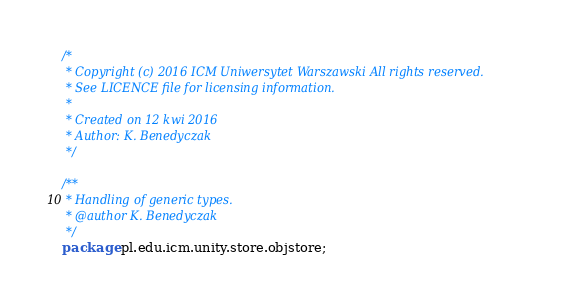<code> <loc_0><loc_0><loc_500><loc_500><_Java_>/*
 * Copyright (c) 2016 ICM Uniwersytet Warszawski All rights reserved.
 * See LICENCE file for licensing information.
 *
 * Created on 12 kwi 2016
 * Author: K. Benedyczak
 */

/**
 * Handling of generic types. 
 * @author K. Benedyczak
 */
package pl.edu.icm.unity.store.objstore;</code> 